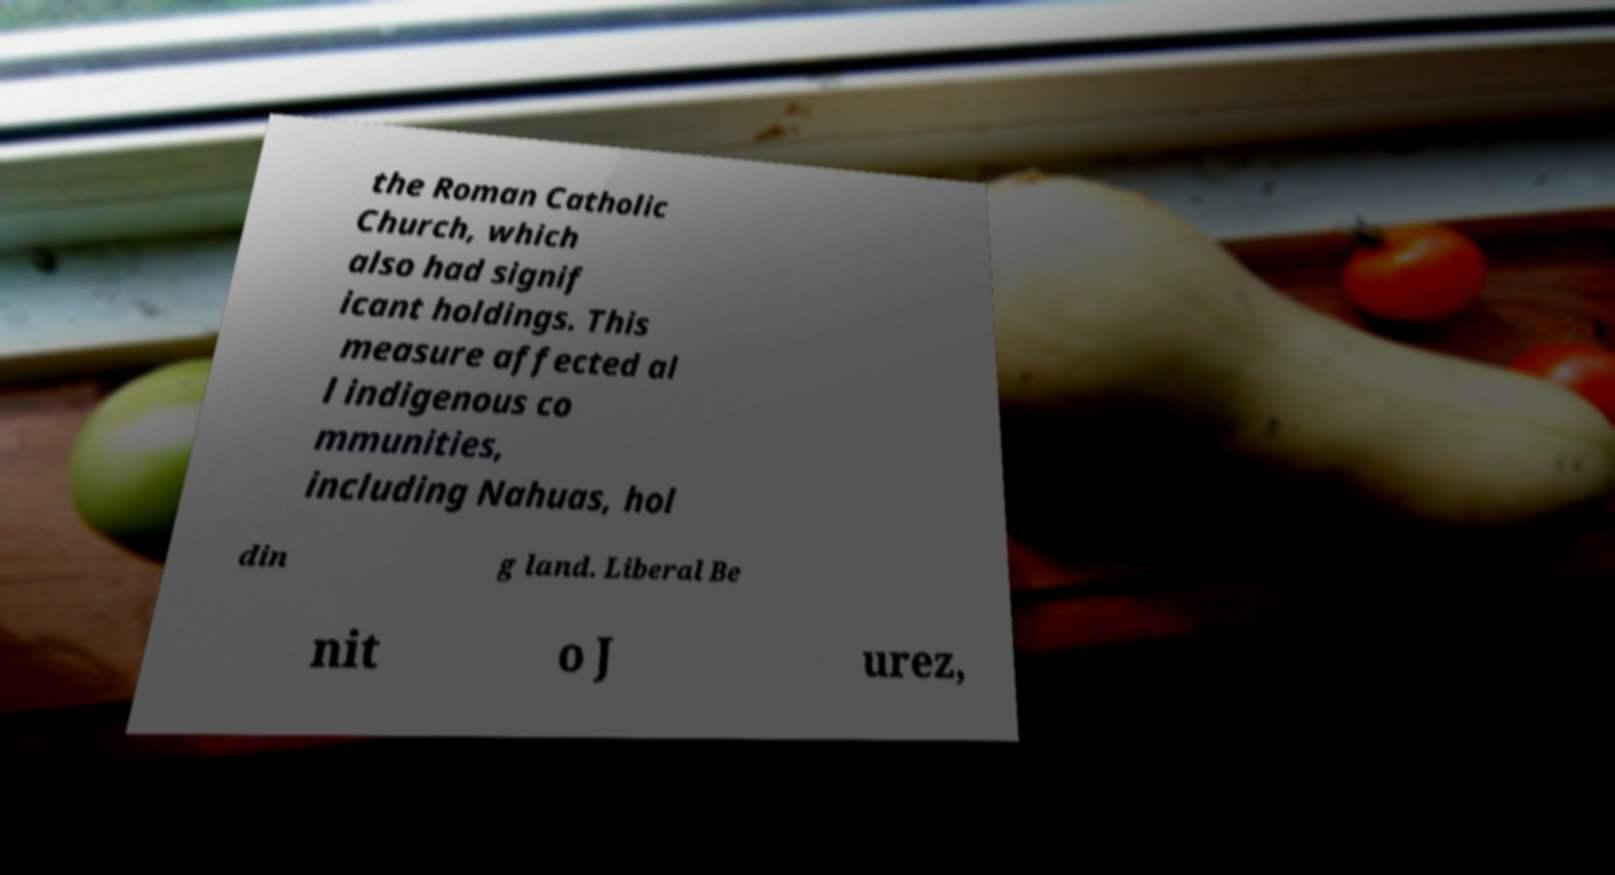There's text embedded in this image that I need extracted. Can you transcribe it verbatim? the Roman Catholic Church, which also had signif icant holdings. This measure affected al l indigenous co mmunities, including Nahuas, hol din g land. Liberal Be nit o J urez, 